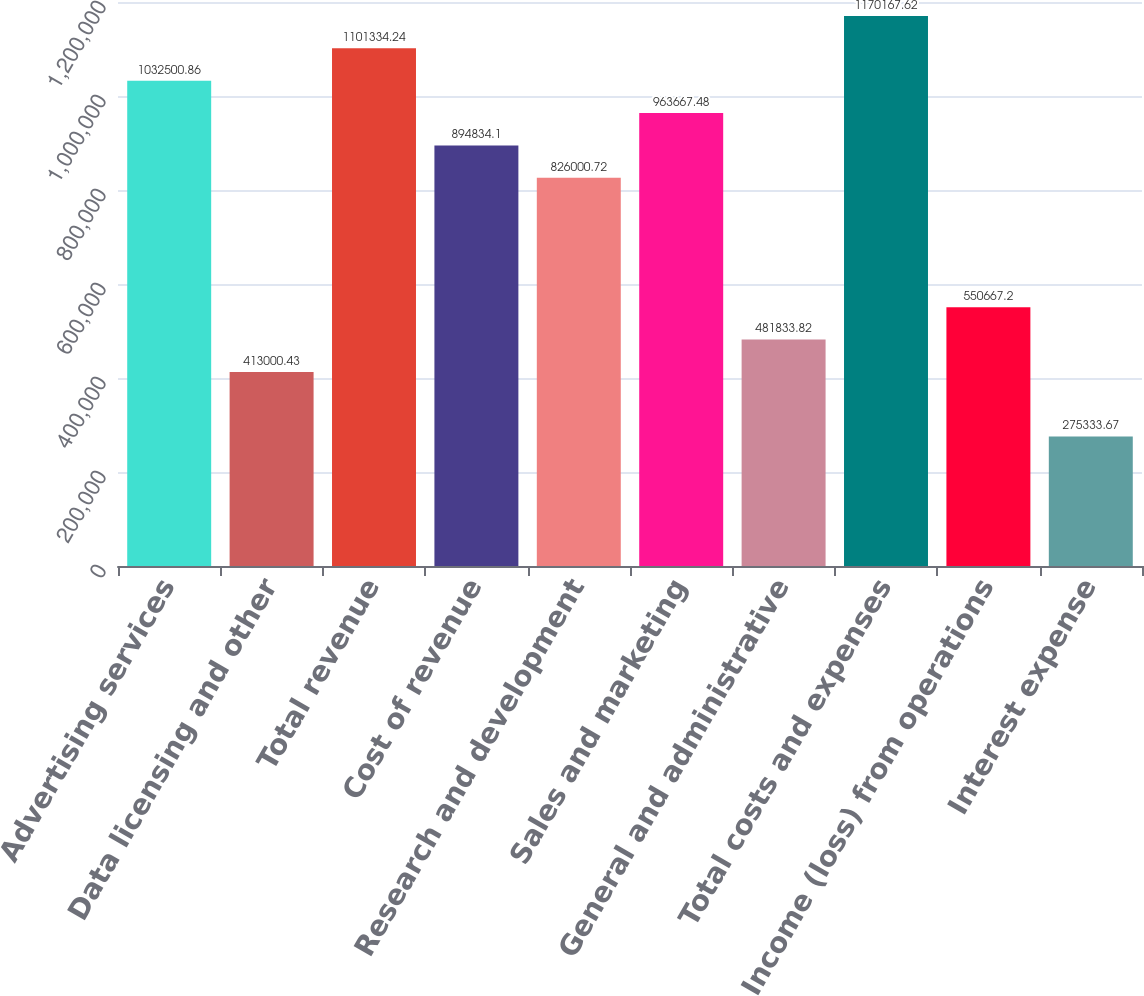Convert chart. <chart><loc_0><loc_0><loc_500><loc_500><bar_chart><fcel>Advertising services<fcel>Data licensing and other<fcel>Total revenue<fcel>Cost of revenue<fcel>Research and development<fcel>Sales and marketing<fcel>General and administrative<fcel>Total costs and expenses<fcel>Income (loss) from operations<fcel>Interest expense<nl><fcel>1.0325e+06<fcel>413000<fcel>1.10133e+06<fcel>894834<fcel>826001<fcel>963667<fcel>481834<fcel>1.17017e+06<fcel>550667<fcel>275334<nl></chart> 